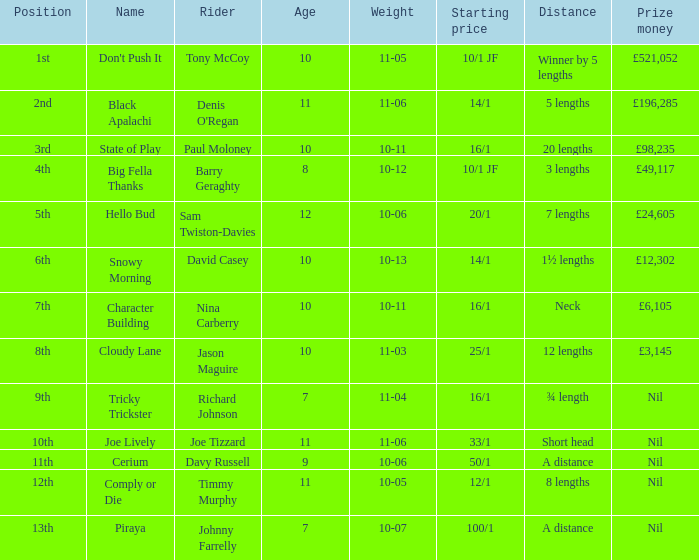 How much did Nina Carberry win?  £6,105. 